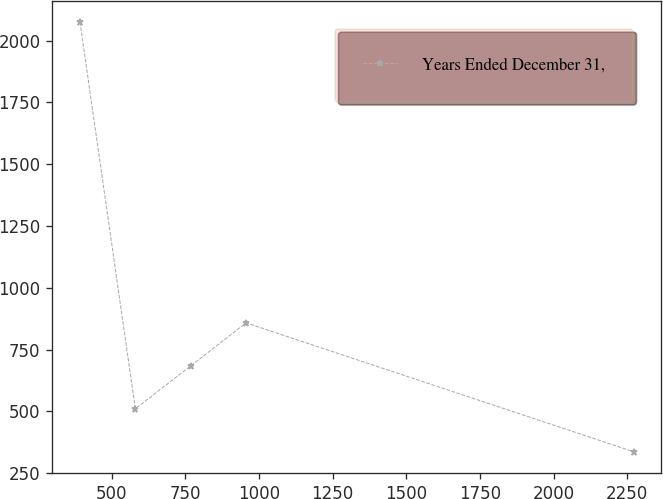<chart> <loc_0><loc_0><loc_500><loc_500><line_chart><ecel><fcel>Years Ended December 31,<nl><fcel>392.66<fcel>2074.79<nl><fcel>580.6<fcel>510.37<nl><fcel>768.54<fcel>684.2<nl><fcel>956.48<fcel>858.03<nl><fcel>2272.03<fcel>336.54<nl></chart> 